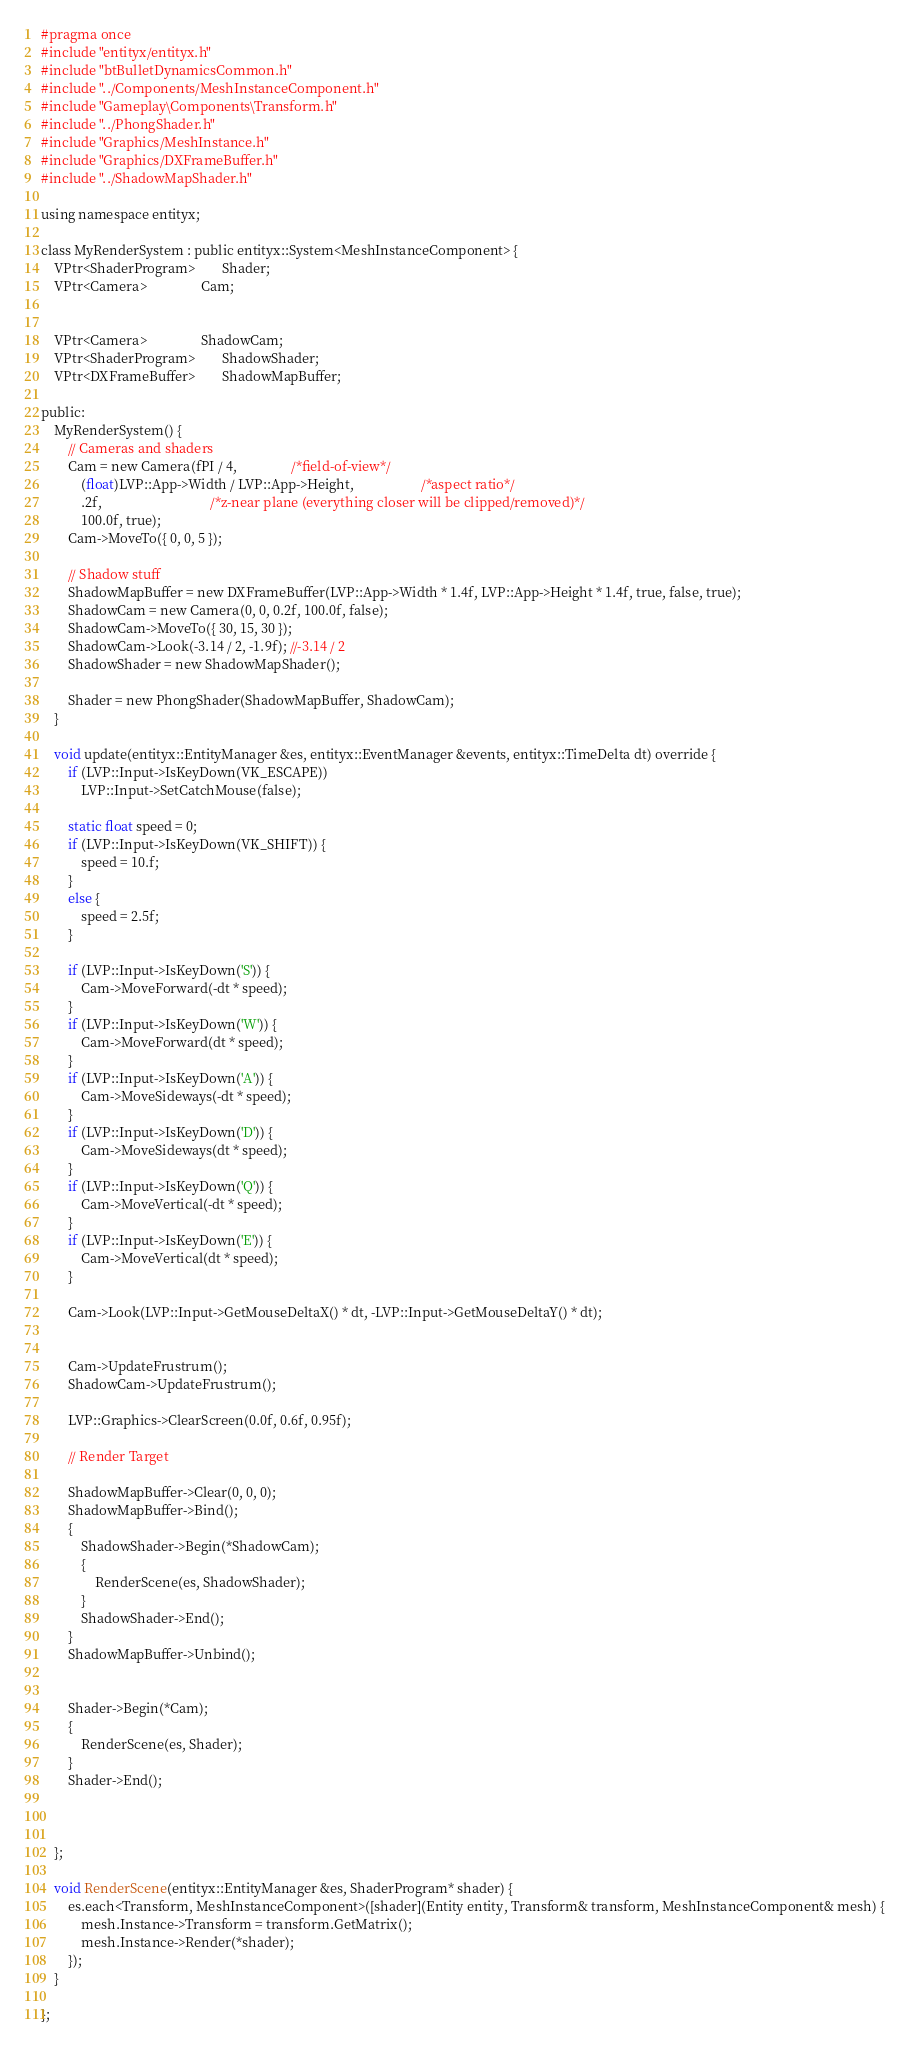Convert code to text. <code><loc_0><loc_0><loc_500><loc_500><_C_>#pragma once
#include "entityx/entityx.h"
#include "btBulletDynamicsCommon.h"
#include "../Components/MeshInstanceComponent.h"
#include "Gameplay\Components\Transform.h"
#include "../PhongShader.h"
#include "Graphics/MeshInstance.h"
#include "Graphics/DXFrameBuffer.h"
#include "../ShadowMapShader.h"

using namespace entityx;

class MyRenderSystem : public entityx::System<MeshInstanceComponent> {
	VPtr<ShaderProgram>		Shader;
	VPtr<Camera>				Cam;


	VPtr<Camera>				ShadowCam;
	VPtr<ShaderProgram>		ShadowShader;
	VPtr<DXFrameBuffer>		ShadowMapBuffer;

public:
	MyRenderSystem() {
		// Cameras and shaders
		Cam = new Camera(fPI / 4,				/*field-of-view*/
			(float)LVP::App->Width / LVP::App->Height,					/*aspect ratio*/
			.2f,								/*z-near plane (everything closer will be clipped/removed)*/
			100.0f, true);
		Cam->MoveTo({ 0, 0, 5 });

		// Shadow stuff
		ShadowMapBuffer = new DXFrameBuffer(LVP::App->Width * 1.4f, LVP::App->Height * 1.4f, true, false, true);
		ShadowCam = new Camera(0, 0, 0.2f, 100.0f, false);
		ShadowCam->MoveTo({ 30, 15, 30 });
		ShadowCam->Look(-3.14 / 2, -1.9f); //-3.14 / 2
		ShadowShader = new ShadowMapShader();

		Shader = new PhongShader(ShadowMapBuffer, ShadowCam);
	}

	void update(entityx::EntityManager &es, entityx::EventManager &events, entityx::TimeDelta dt) override {
		if (LVP::Input->IsKeyDown(VK_ESCAPE))
			LVP::Input->SetCatchMouse(false);

		static float speed = 0;
		if (LVP::Input->IsKeyDown(VK_SHIFT)) {
			speed = 10.f;
		}
		else {
			speed = 2.5f;
		}

		if (LVP::Input->IsKeyDown('S')) {
			Cam->MoveForward(-dt * speed);
		}
		if (LVP::Input->IsKeyDown('W')) {
			Cam->MoveForward(dt * speed);
		}
		if (LVP::Input->IsKeyDown('A')) {
			Cam->MoveSideways(-dt * speed);
		}
		if (LVP::Input->IsKeyDown('D')) {
			Cam->MoveSideways(dt * speed);
		}
		if (LVP::Input->IsKeyDown('Q')) {
			Cam->MoveVertical(-dt * speed);
		}
		if (LVP::Input->IsKeyDown('E')) {
			Cam->MoveVertical(dt * speed);
		}

		Cam->Look(LVP::Input->GetMouseDeltaX() * dt, -LVP::Input->GetMouseDeltaY() * dt);


		Cam->UpdateFrustrum();
		ShadowCam->UpdateFrustrum();

		LVP::Graphics->ClearScreen(0.0f, 0.6f, 0.95f);

		// Render Target

		ShadowMapBuffer->Clear(0, 0, 0);
		ShadowMapBuffer->Bind();
		{
			ShadowShader->Begin(*ShadowCam);
			{
				RenderScene(es, ShadowShader);
			}
			ShadowShader->End();
		}
		ShadowMapBuffer->Unbind();


		Shader->Begin(*Cam);
		{
			RenderScene(es, Shader);
		}
		Shader->End();

		

	};

	void RenderScene(entityx::EntityManager &es, ShaderProgram* shader) {
		es.each<Transform, MeshInstanceComponent>([shader](Entity entity, Transform& transform, MeshInstanceComponent& mesh) {
			mesh.Instance->Transform = transform.GetMatrix();
			mesh.Instance->Render(*shader);
		});
	}

};

</code> 